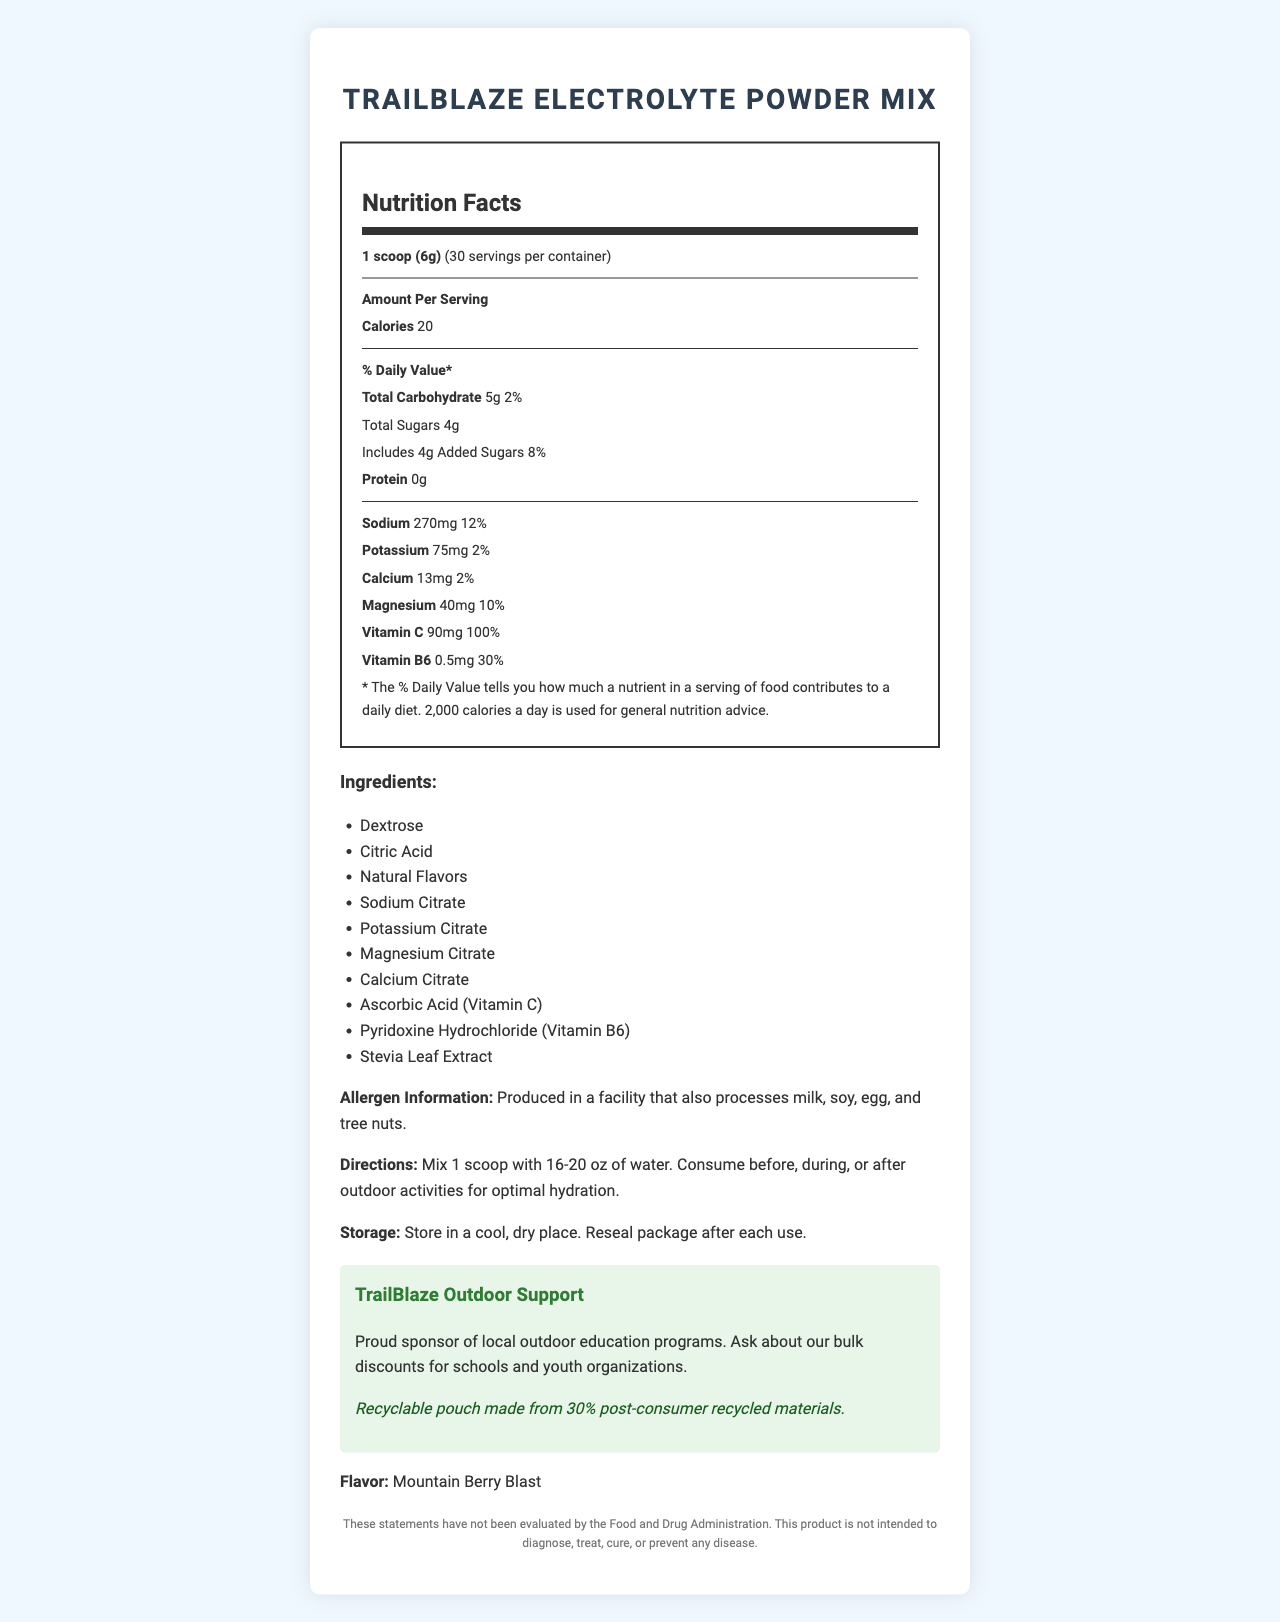when mixed with water as directed, how many calories does one serving of the TrailBlaze Electrolyte Powder Mix provide? The document states that one serving contains 20 calories.
Answer: 20 how much sodium is in a serving of TrailBlaze Electrolyte Powder Mix? The nutrition label indicates that a serving contains 270mg of sodium.
Answer: 270mg how many servings are there per container? The document mentions that there are 30 servings per container.
Answer: 30 what percentage of the daily value of Vitamin C is provided by one serving? The nutrition label shows that a serving of the powder mix provides 100% of the daily value for Vitamin C.
Answer: 100% what is the serving size for TrailBlaze Electrolyte Powder Mix? The document indicates that the serving size is one scoop, which is 6 grams.
Answer: 1 scoop (6g) which of the following ingredients is not listed in TrailBlaze Electrolyte Powder Mix? A. Dextrose B. Citric Acid C. Sodium Chloride D. Stevia Leaf Extract The ingredients listed include Dextrose, Citric Acid, Natural Flavors, Sodium Citrate, Potassium Citrate, Magnesium Citrate, Calcium Citrate, Ascorbic Acid (Vitamin C), Pyridoxine Hydrochloride (Vitamin B6), and Stevia Leaf Extract, but not Sodium Chloride.
Answer: C. Sodium Chloride What is the flavor of TrailBlaze Electrolyte Powder Mix? A. Citrus Splash B. Mountain Berry Blast C. Tropical Punch D. Lemon Lime The document specifies that the flavor is Mountain Berry Blast.
Answer: B. Mountain Berry Blast Does TrailBlaze Electrolyte Powder Mix contain any protein? The nutrition label indicates that there is 0g of protein per serving.
Answer: No Is the packaging of the TrailBlaze Electrolyte Powder Mix recyclable? The document states that the pouch is recyclable and made from 30% post-consumer recycled materials.
Answer: Yes can you determine the exact manufacturing process facility for TrailBlaze Electrolyte Powder Mix? The document does not provide detailed information about the exact manufacturing process facility.
Answer: Not enough information Provide a summary of the main details of the TrailBlaze Electrolyte Powder Mix document. The document provides comprehensive information about the TrailBlaze Electrolyte Powder Mix, detailing its nutritional content, ingredients, allergy information, usage directions, storage instructions, and environmental and community support initiatives.
Answer: The TrailBlaze Electrolyte Powder Mix is a hydration product designed for outdoor activities. It offers key electrolytes and vitamins, including sodium and Vitamin C, to maintain hydration. The product comes in a Mountain Berry Blast flavor, contains 0g of protein, and provides 20 calories per serving, with each container offering 30 servings. The product is made with several ingredients including Dextrose and Stevia Leaf Extract and is produced in a facility that handles various allergens. It comes in eco-friendly, recyclable packaging. The product supports local outdoor education programs and offers bulk discounts for schools and youth organizations. 